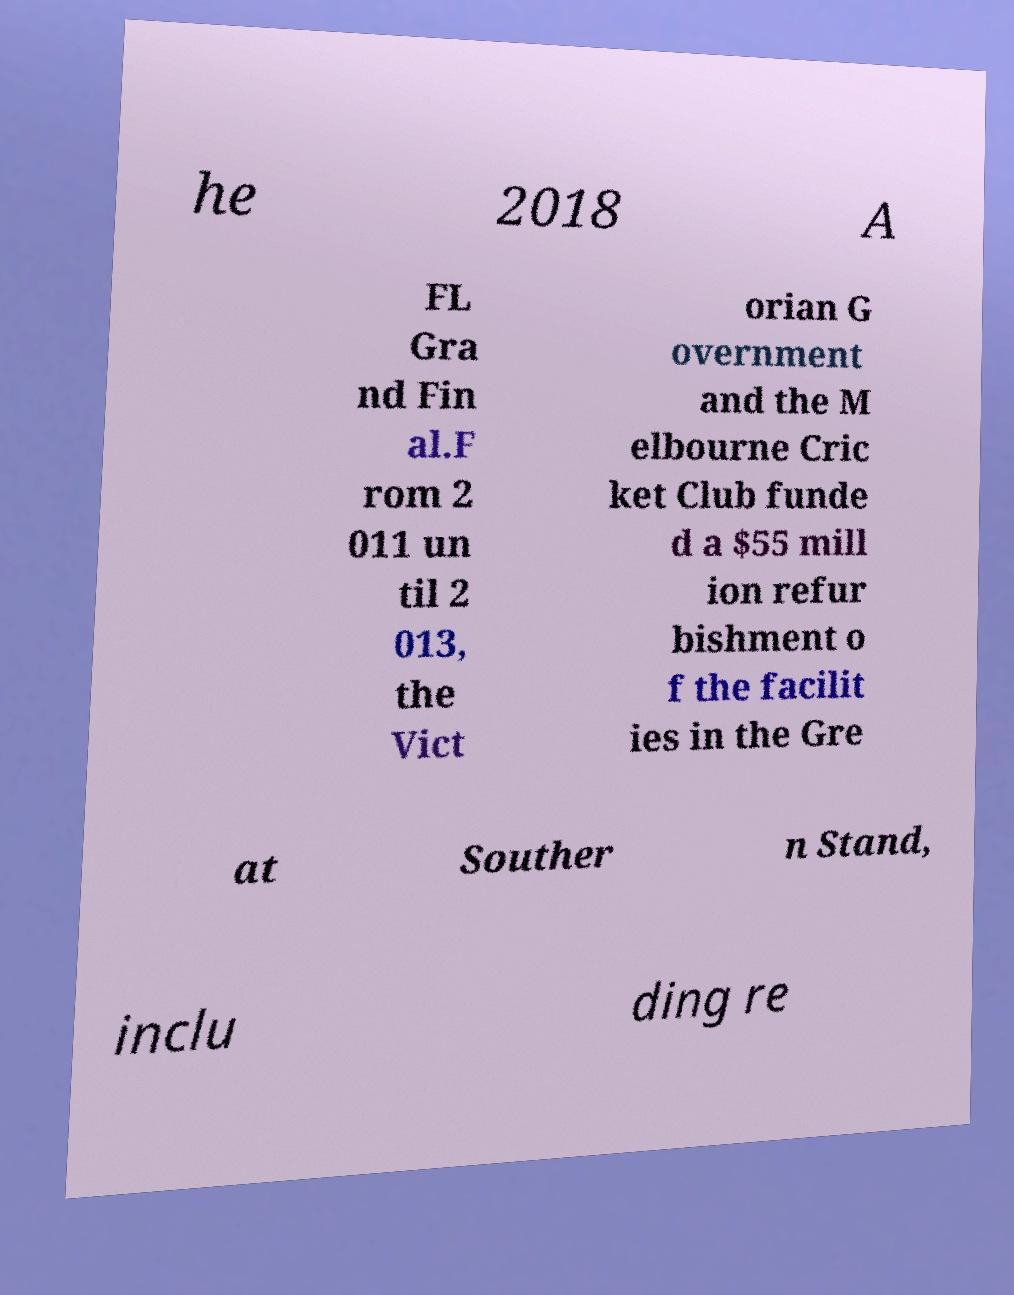Can you accurately transcribe the text from the provided image for me? he 2018 A FL Gra nd Fin al.F rom 2 011 un til 2 013, the Vict orian G overnment and the M elbourne Cric ket Club funde d a $55 mill ion refur bishment o f the facilit ies in the Gre at Souther n Stand, inclu ding re 